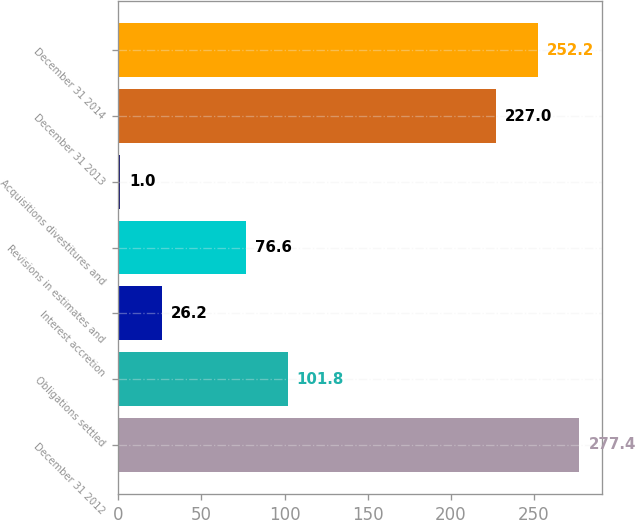<chart> <loc_0><loc_0><loc_500><loc_500><bar_chart><fcel>December 31 2012<fcel>Obligations settled<fcel>Interest accretion<fcel>Revisions in estimates and<fcel>Acquisitions divestitures and<fcel>December 31 2013<fcel>December 31 2014<nl><fcel>277.4<fcel>101.8<fcel>26.2<fcel>76.6<fcel>1<fcel>227<fcel>252.2<nl></chart> 